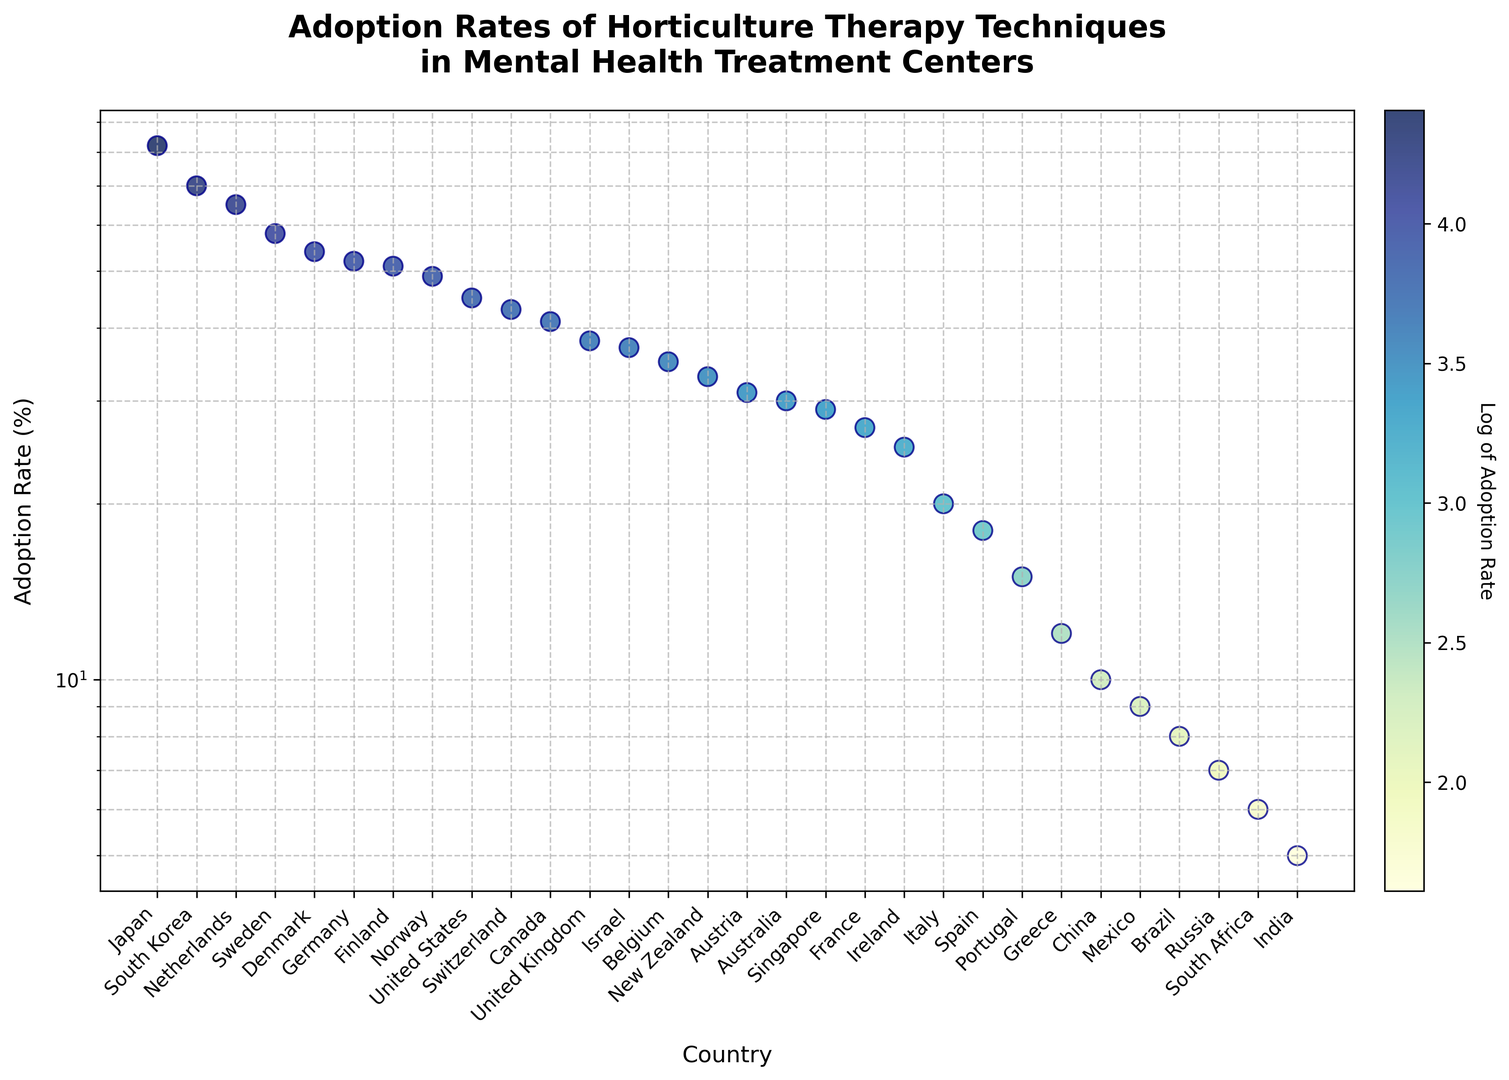Which country has the highest adoption rate of horticulture therapy techniques? By observing the highest data point on the y-axis, Japan is at the top with an adoption rate of 82%.
Answer: Japan Which country has the lowest adoption rate? By observing the lowest data point on the y-axis, India is at the bottom with an adoption rate of 5%.
Answer: India What is the difference in adoption rates between the United States and the United Kingdom? The United States has an adoption rate of 45% and the United Kingdom has 38%. The difference is 45 - 38 = 7%.
Answer: 7% Which countries have adoption rates between 50% and 60%? By observing the data points between 50% and 60% on the y-axis, the countries are Sweden (58%), Germany (52%), Denmark (54%), and Finland (51%).
Answer: Sweden, Germany, Denmark, Finland How does the adoption rate in the Netherlands compare to that in Switzerland? The Netherlands has an adoption rate of 65%, while Switzerland has 43%. 65% > 43%, so the Netherlands has a higher adoption rate.
Answer: The Netherlands has a higher adoption rate, 65% compared to 43% What is the average adoption rate of the top five countries with the highest rates? The top five countries are Japan (82%), South Korea (70%), the Netherlands (65%), Sweden (58%), and Denmark (54%). The average adoption rate is (82 + 70 + 65 + 58 + 54) / 5 = 65.8%.
Answer: 65.8% How do the adoption rates of Australia and New Zealand compare visually? Australia (30%) and New Zealand (33%) fall in a similar range. Both countries have points close to each other just above 30%.
Answer: New Zealand has a slightly higher adoption rate, 33% compared to 30% Which countries have an adoption rate below 10%? By observing the data points below the 10% mark on the y-axis, the countries are India (5%), South Africa (6%), Russia (7%), Brazil (8%), and Mexico (9%).
Answer: India, South Africa, Russia, Brazil, Mexico What is the adoption rate range within the European countries shown in the chart? The highest rate in a European country is in the Netherlands at 65%, and the lowest is in Greece at 12%. The range is 65% - 12% = 53%.
Answer: 53% Which country has an adoption rate closest to the median of all countries in the chart? To find the median country, list all rates in order and find the middle value. The median adoption rate is around 35%. Belgium, with an adoption rate of 35%, is closest to the median.
Answer: Belgium 